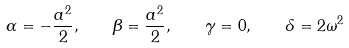Convert formula to latex. <formula><loc_0><loc_0><loc_500><loc_500>\alpha = - \frac { a ^ { 2 } } { 2 } , \quad \beta = \frac { a ^ { 2 } } { 2 } , \quad \gamma = 0 , \quad \delta = 2 \omega ^ { 2 }</formula> 